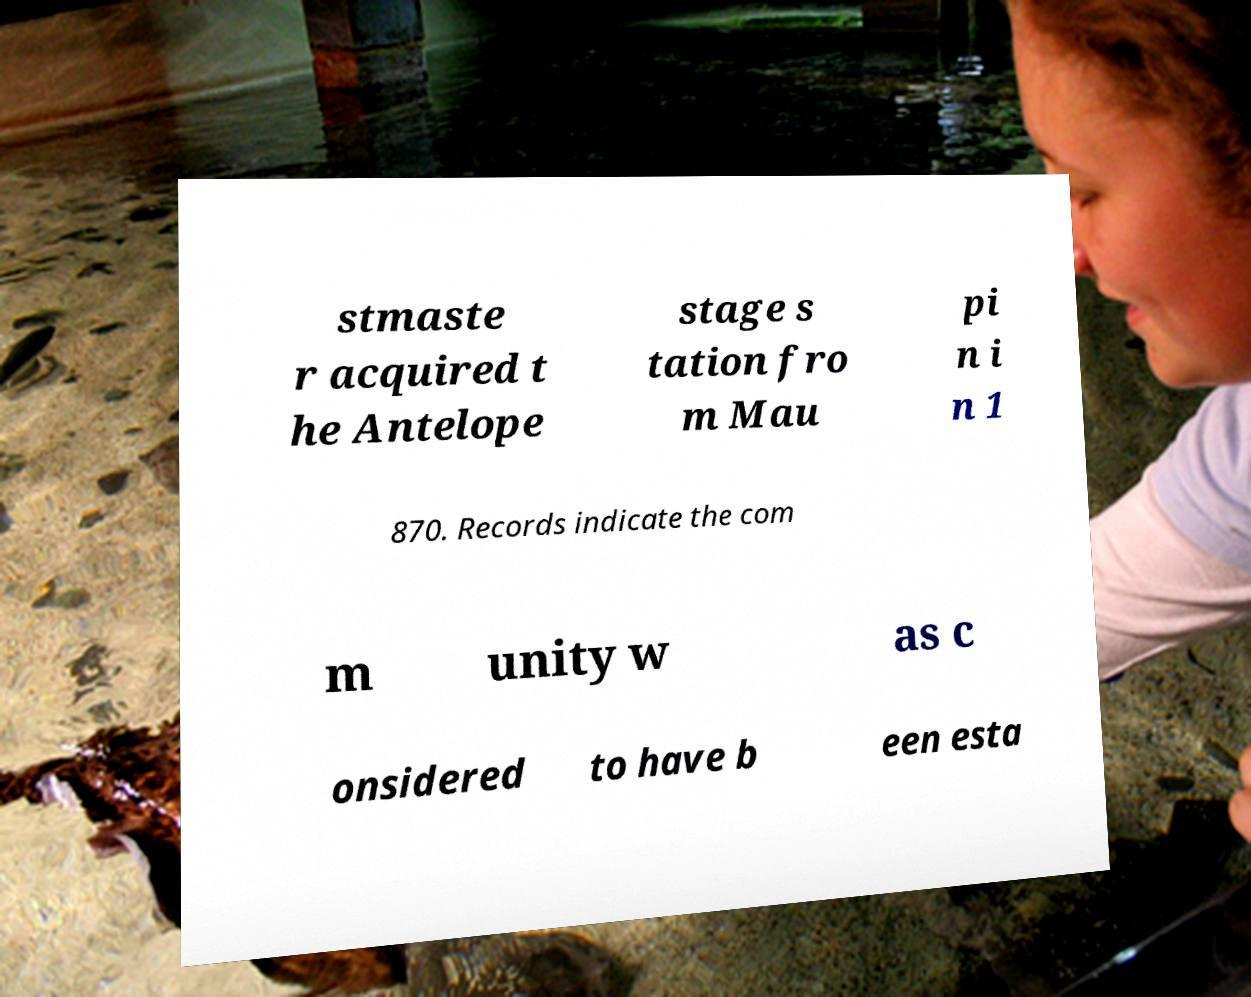Please read and relay the text visible in this image. What does it say? stmaste r acquired t he Antelope stage s tation fro m Mau pi n i n 1 870. Records indicate the com m unity w as c onsidered to have b een esta 